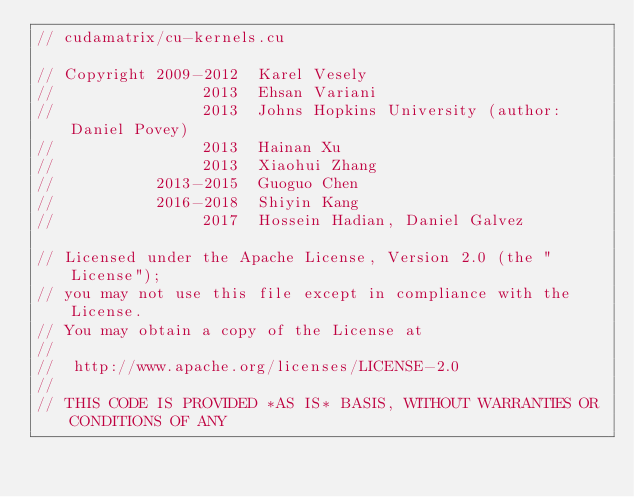Convert code to text. <code><loc_0><loc_0><loc_500><loc_500><_Cuda_>// cudamatrix/cu-kernels.cu

// Copyright 2009-2012  Karel Vesely
//                2013  Ehsan Variani
//                2013  Johns Hopkins University (author: Daniel Povey)
//                2013  Hainan Xu
//                2013  Xiaohui Zhang
//           2013-2015  Guoguo Chen
//           2016-2018  Shiyin Kang
//                2017  Hossein Hadian, Daniel Galvez

// Licensed under the Apache License, Version 2.0 (the "License");
// you may not use this file except in compliance with the License.
// You may obtain a copy of the License at
//
//  http://www.apache.org/licenses/LICENSE-2.0
//
// THIS CODE IS PROVIDED *AS IS* BASIS, WITHOUT WARRANTIES OR CONDITIONS OF ANY</code> 